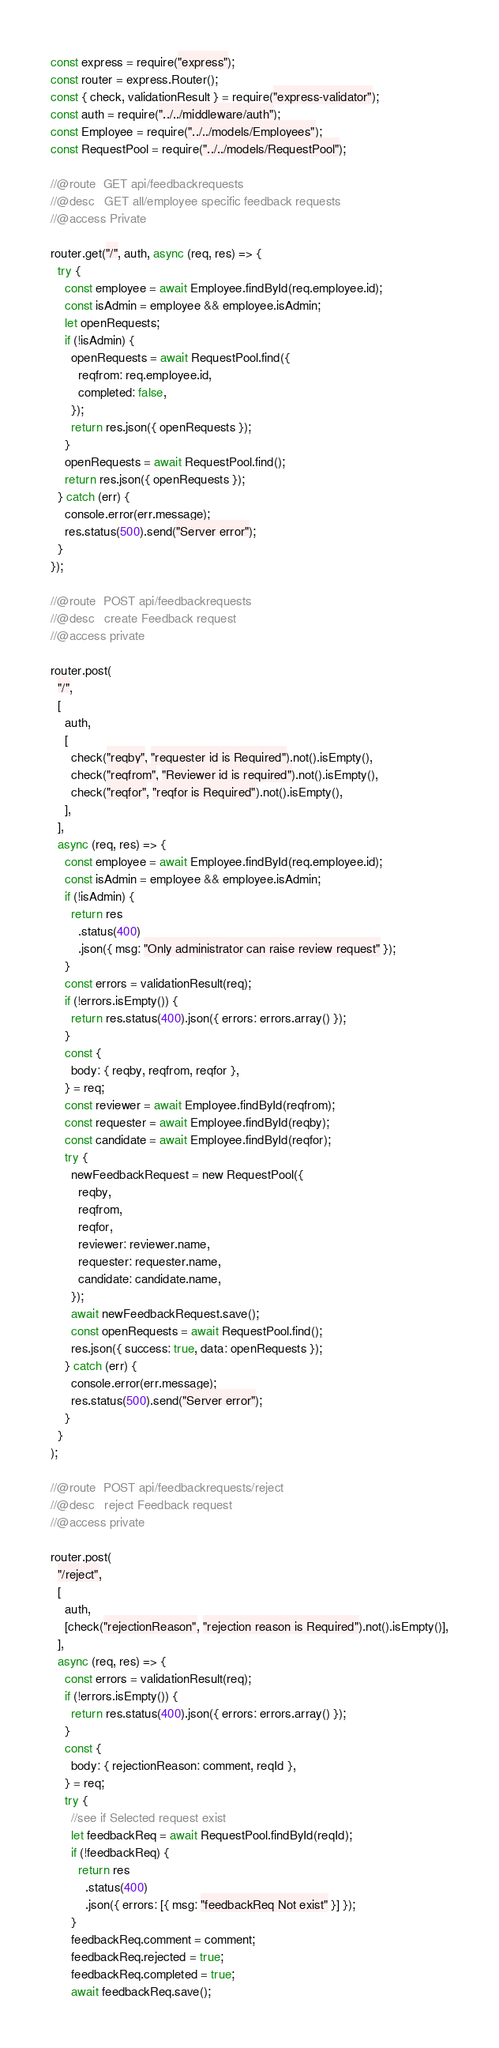<code> <loc_0><loc_0><loc_500><loc_500><_JavaScript_>const express = require("express");
const router = express.Router();
const { check, validationResult } = require("express-validator");
const auth = require("../../middleware/auth");
const Employee = require("../../models/Employees");
const RequestPool = require("../../models/RequestPool");

//@route  GET api/feedbackrequests
//@desc   GET all/employee specific feedback requests
//@access Private

router.get("/", auth, async (req, res) => {
  try {
    const employee = await Employee.findById(req.employee.id);
    const isAdmin = employee && employee.isAdmin;
    let openRequests;
    if (!isAdmin) {
      openRequests = await RequestPool.find({
        reqfrom: req.employee.id,
        completed: false,
      });
      return res.json({ openRequests });
    }
    openRequests = await RequestPool.find();
    return res.json({ openRequests });
  } catch (err) {
    console.error(err.message);
    res.status(500).send("Server error");
  }
});

//@route  POST api/feedbackrequests
//@desc   create Feedback request
//@access private

router.post(
  "/",
  [
    auth,
    [
      check("reqby", "requester id is Required").not().isEmpty(),
      check("reqfrom", "Reviewer id is required").not().isEmpty(),
      check("reqfor", "reqfor is Required").not().isEmpty(),
    ],
  ],
  async (req, res) => {
    const employee = await Employee.findById(req.employee.id);
    const isAdmin = employee && employee.isAdmin;
    if (!isAdmin) {
      return res
        .status(400)
        .json({ msg: "Only administrator can raise review request" });
    }
    const errors = validationResult(req);
    if (!errors.isEmpty()) {
      return res.status(400).json({ errors: errors.array() });
    }
    const {
      body: { reqby, reqfrom, reqfor },
    } = req;
    const reviewer = await Employee.findById(reqfrom);
    const requester = await Employee.findById(reqby);
    const candidate = await Employee.findById(reqfor);
    try {
      newFeedbackRequest = new RequestPool({
        reqby,
        reqfrom,
        reqfor,
        reviewer: reviewer.name,
        requester: requester.name,
        candidate: candidate.name,
      });
      await newFeedbackRequest.save();
      const openRequests = await RequestPool.find();
      res.json({ success: true, data: openRequests });
    } catch (err) {
      console.error(err.message);
      res.status(500).send("Server error");
    }
  }
);

//@route  POST api/feedbackrequests/reject
//@desc   reject Feedback request
//@access private

router.post(
  "/reject",
  [
    auth,
    [check("rejectionReason", "rejection reason is Required").not().isEmpty()],
  ],
  async (req, res) => {
    const errors = validationResult(req);
    if (!errors.isEmpty()) {
      return res.status(400).json({ errors: errors.array() });
    }
    const {
      body: { rejectionReason: comment, reqId },
    } = req;
    try {
      //see if Selected request exist
      let feedbackReq = await RequestPool.findById(reqId);
      if (!feedbackReq) {
        return res
          .status(400)
          .json({ errors: [{ msg: "feedbackReq Not exist" }] });
      }
      feedbackReq.comment = comment;
      feedbackReq.rejected = true;
      feedbackReq.completed = true;
      await feedbackReq.save();</code> 